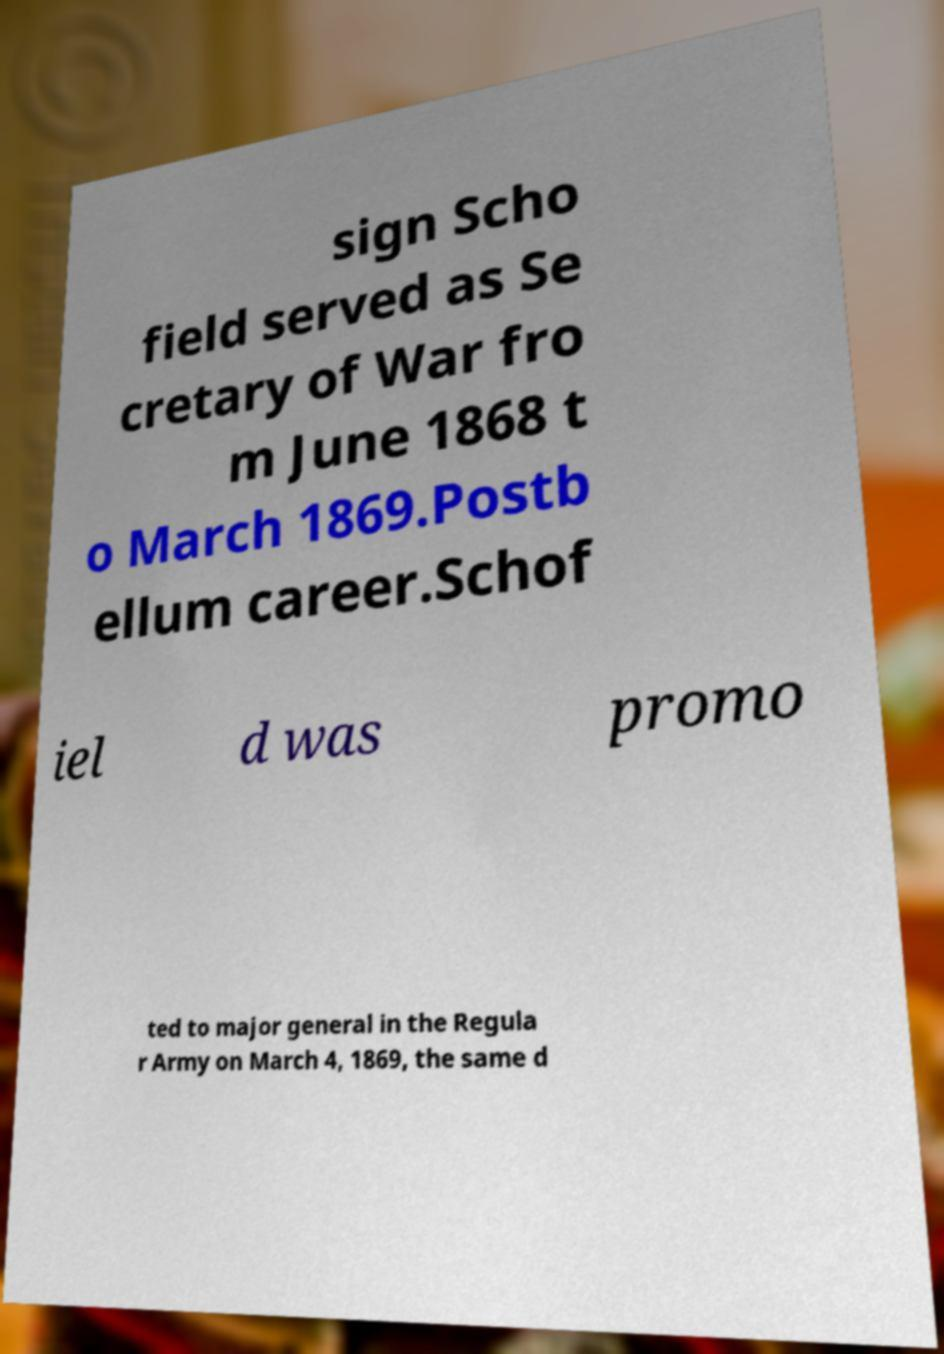Can you read and provide the text displayed in the image?This photo seems to have some interesting text. Can you extract and type it out for me? sign Scho field served as Se cretary of War fro m June 1868 t o March 1869.Postb ellum career.Schof iel d was promo ted to major general in the Regula r Army on March 4, 1869, the same d 